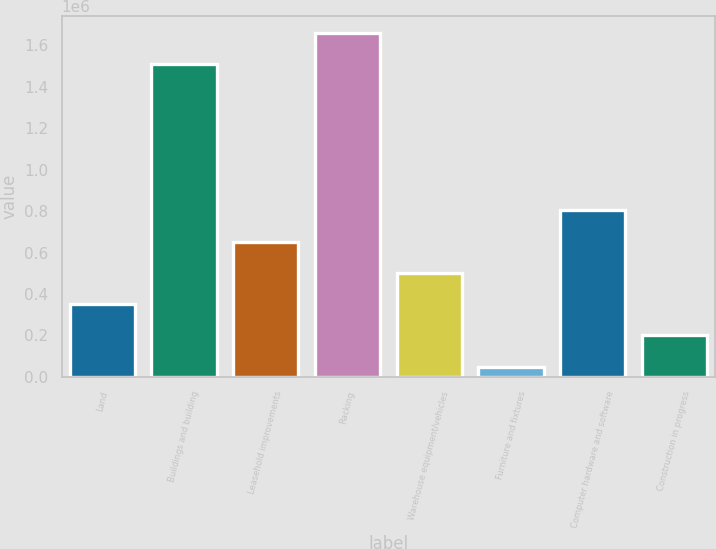Convert chart to OTSL. <chart><loc_0><loc_0><loc_500><loc_500><bar_chart><fcel>Land<fcel>Buildings and building<fcel>Leasehold improvements<fcel>Racking<fcel>Warehouse equipment/vehicles<fcel>Furniture and fixtures<fcel>Computer hardware and software<fcel>Construction in progress<nl><fcel>351595<fcel>1.50722e+06<fcel>652884<fcel>1.65787e+06<fcel>502240<fcel>50307<fcel>803528<fcel>200951<nl></chart> 